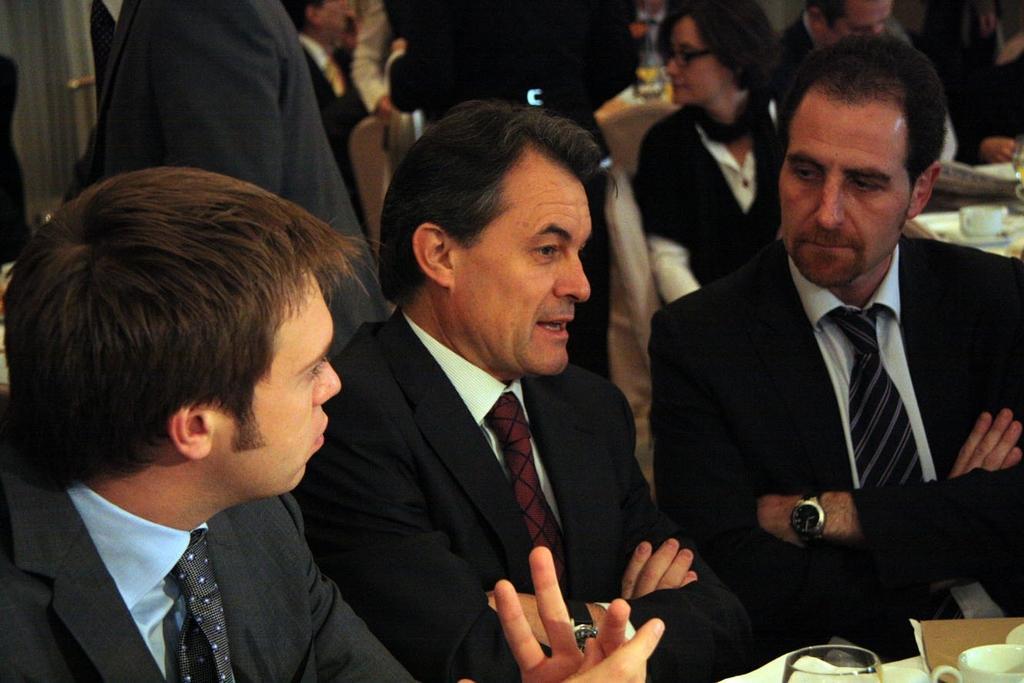Please provide a concise description of this image. In this picture I see 3 men in front who are wearing suits and I see a cup and a glass in front of them. In the background I see few more people and I see the tables on which there are few things. 